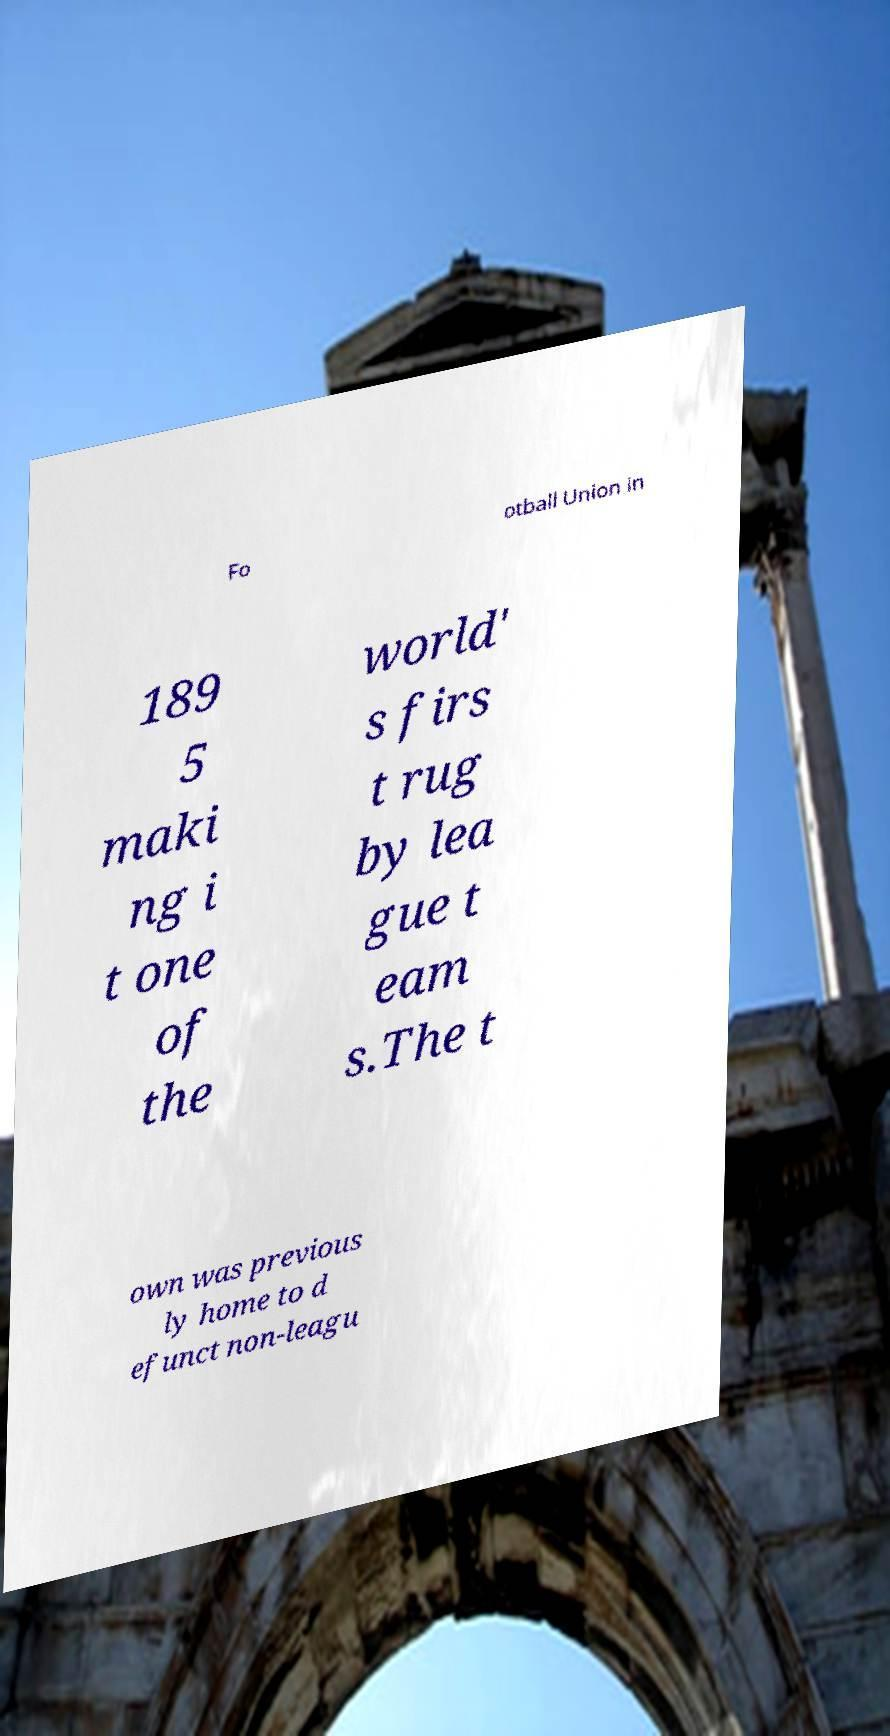I need the written content from this picture converted into text. Can you do that? Fo otball Union in 189 5 maki ng i t one of the world' s firs t rug by lea gue t eam s.The t own was previous ly home to d efunct non-leagu 